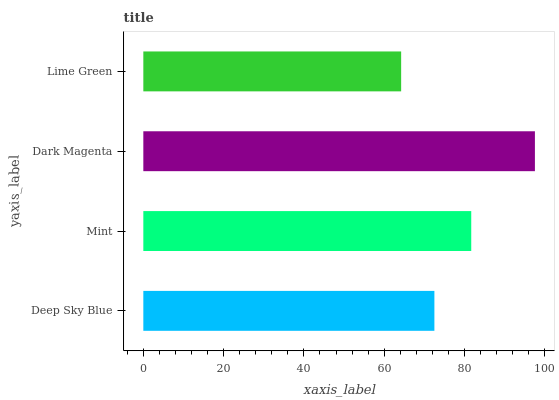Is Lime Green the minimum?
Answer yes or no. Yes. Is Dark Magenta the maximum?
Answer yes or no. Yes. Is Mint the minimum?
Answer yes or no. No. Is Mint the maximum?
Answer yes or no. No. Is Mint greater than Deep Sky Blue?
Answer yes or no. Yes. Is Deep Sky Blue less than Mint?
Answer yes or no. Yes. Is Deep Sky Blue greater than Mint?
Answer yes or no. No. Is Mint less than Deep Sky Blue?
Answer yes or no. No. Is Mint the high median?
Answer yes or no. Yes. Is Deep Sky Blue the low median?
Answer yes or no. Yes. Is Lime Green the high median?
Answer yes or no. No. Is Mint the low median?
Answer yes or no. No. 